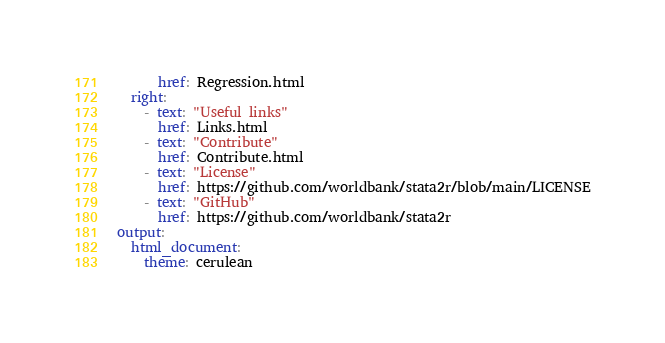Convert code to text. <code><loc_0><loc_0><loc_500><loc_500><_YAML_>      href: Regression.html
  right:
    - text: "Useful links"
      href: Links.html
    - text: "Contribute"
      href: Contribute.html
    - text: "License"
      href: https://github.com/worldbank/stata2r/blob/main/LICENSE
    - text: "GitHub"
      href: https://github.com/worldbank/stata2r
output:
  html_document:
    theme: cerulean
</code> 